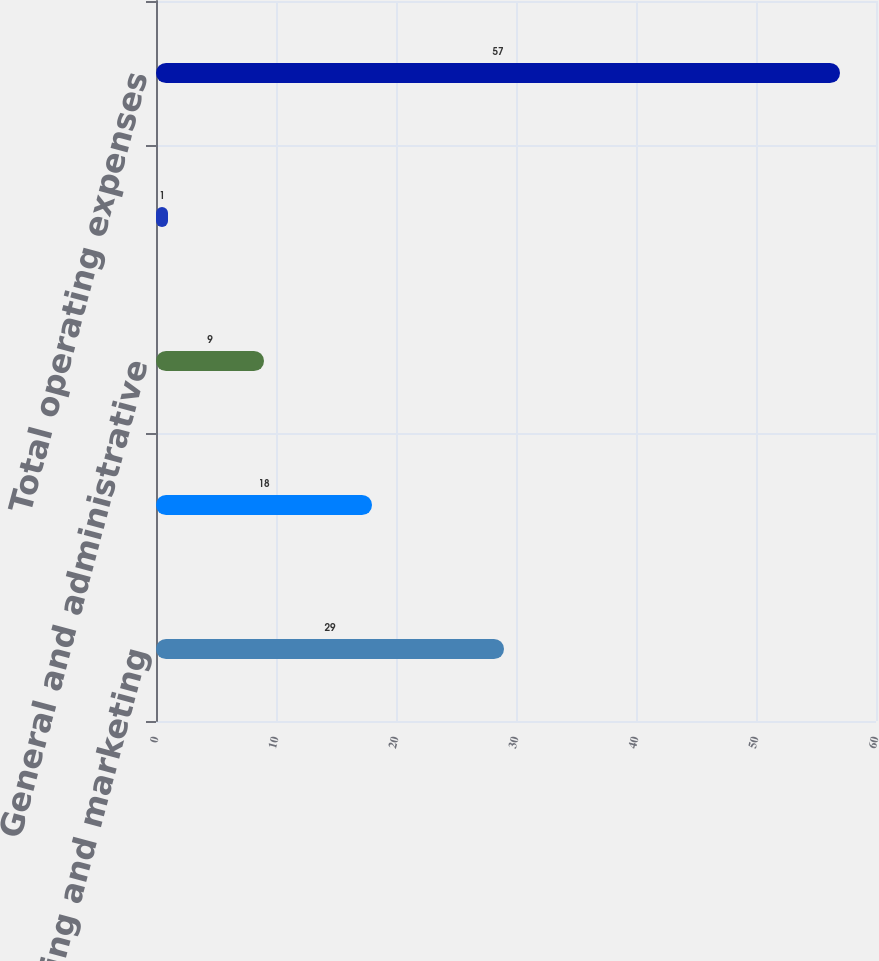Convert chart to OTSL. <chart><loc_0><loc_0><loc_500><loc_500><bar_chart><fcel>Selling and marketing<fcel>Research and development<fcel>General and administrative<fcel>Amortization of other<fcel>Total operating expenses<nl><fcel>29<fcel>18<fcel>9<fcel>1<fcel>57<nl></chart> 